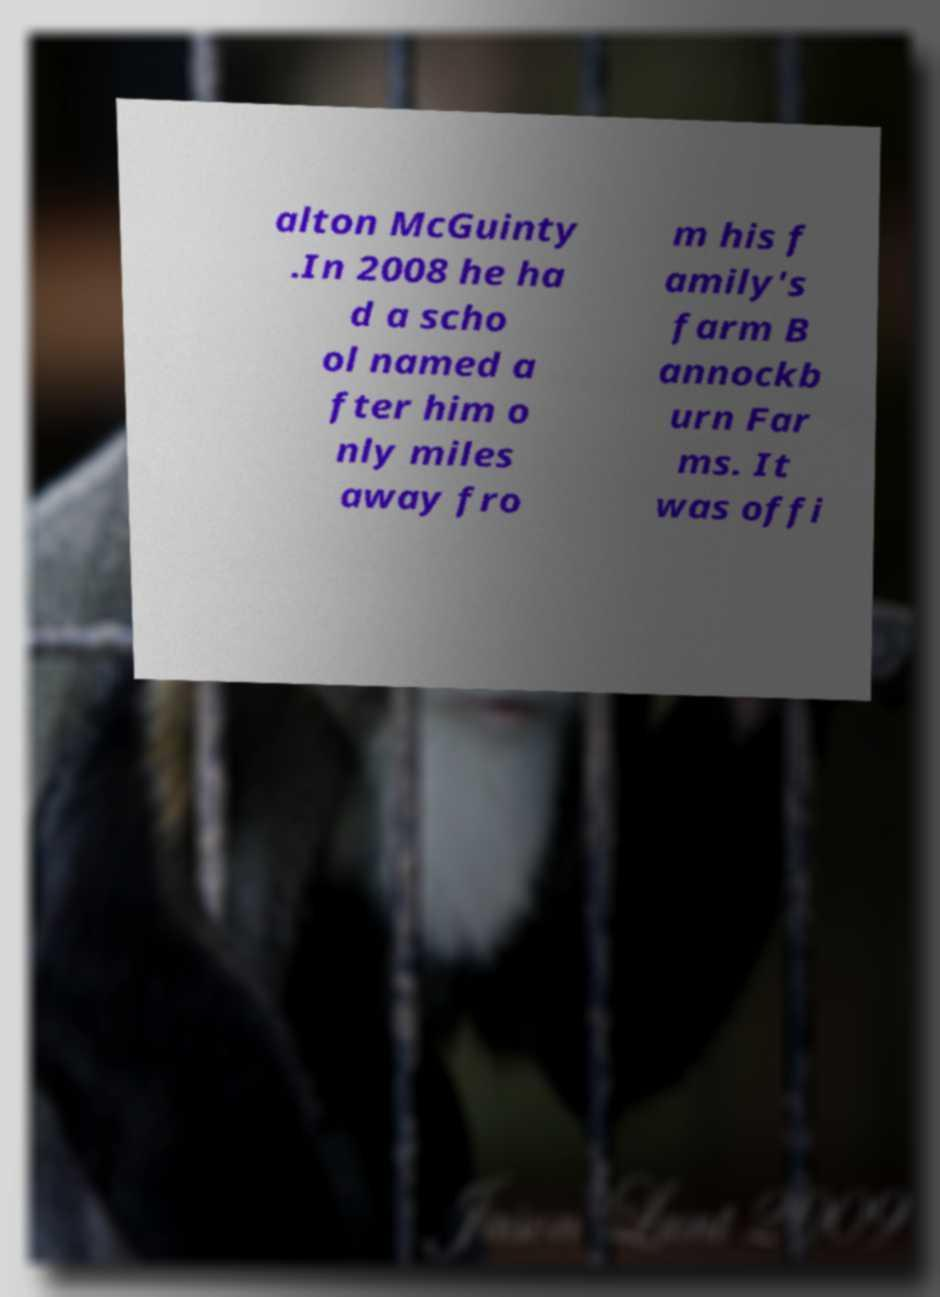Can you read and provide the text displayed in the image?This photo seems to have some interesting text. Can you extract and type it out for me? alton McGuinty .In 2008 he ha d a scho ol named a fter him o nly miles away fro m his f amily's farm B annockb urn Far ms. It was offi 